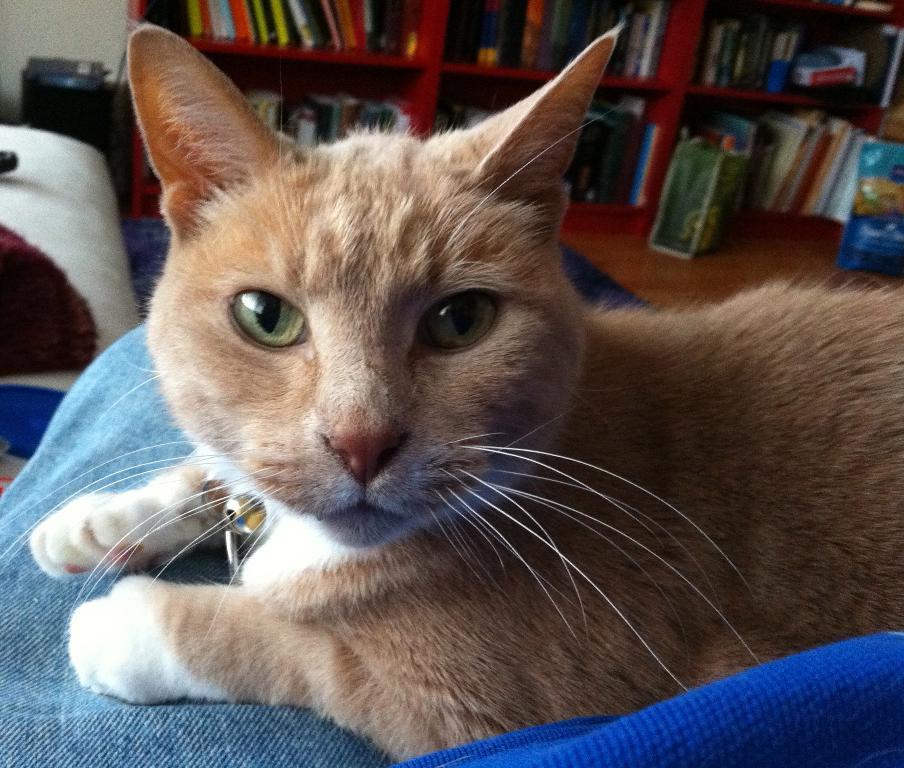In one or two sentences, can you explain what this image depicts? In this picture there is a cat which is lying on the couch. On the back i can see many books which is kept in the wooden shelves. In the top left corner there is a black dustbin near to the wall. Beside that there is a bed. 